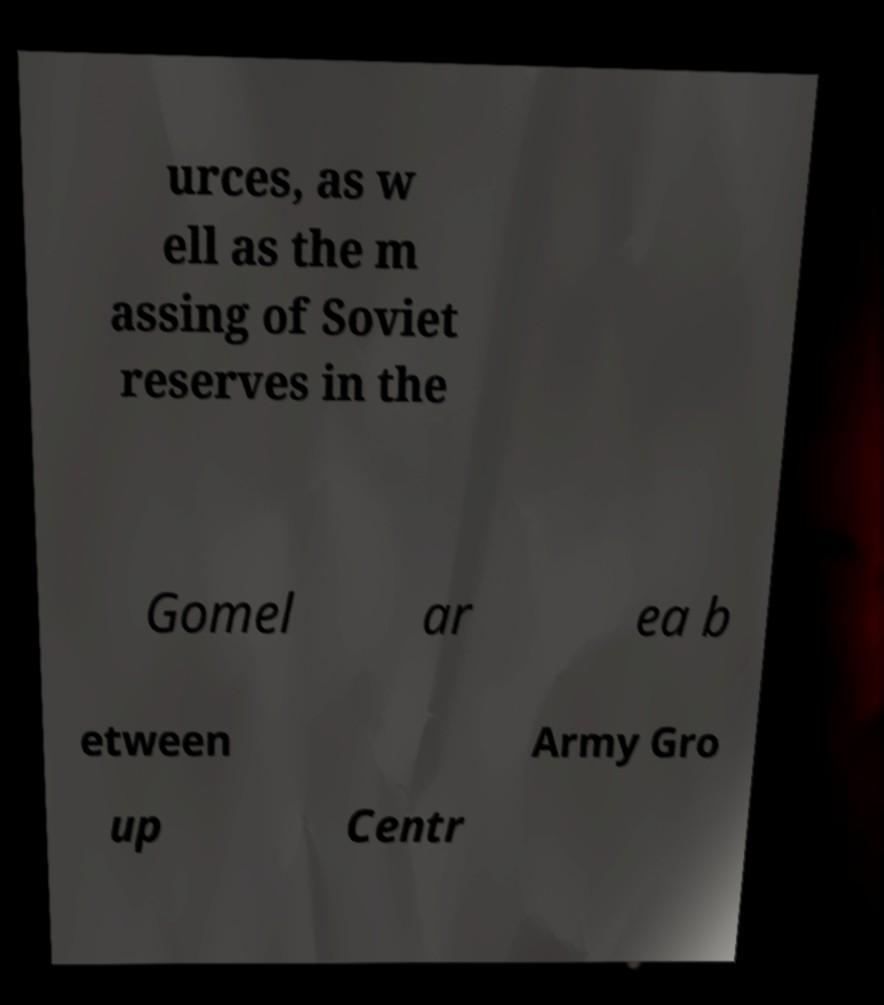What messages or text are displayed in this image? I need them in a readable, typed format. urces, as w ell as the m assing of Soviet reserves in the Gomel ar ea b etween Army Gro up Centr 